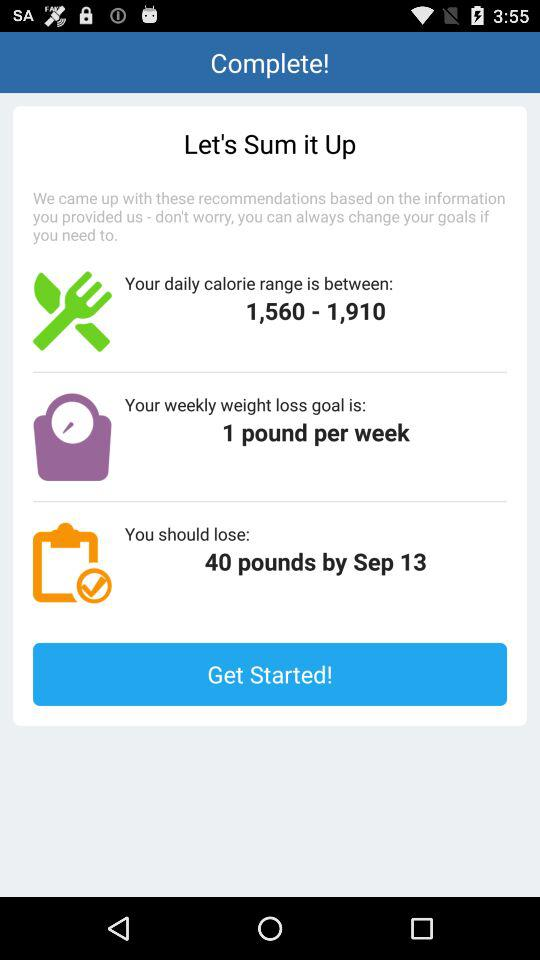What is the weekly weight loss goal? The weekly weight loss goal is 1 pound. 